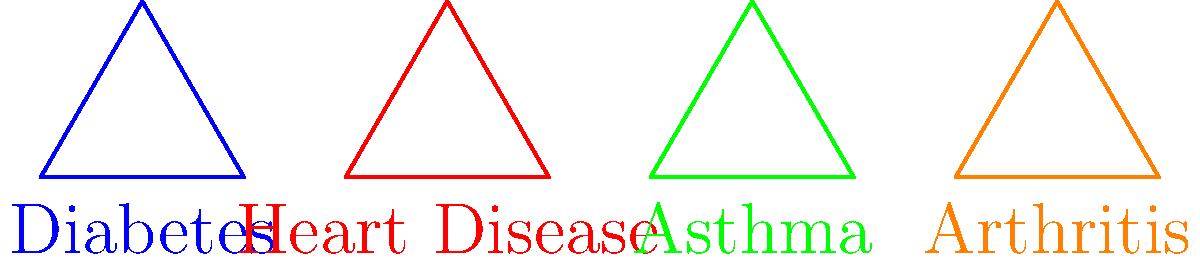In the diagram above, four equilateral triangles represent different coverage options for chronic conditions. Which two triangles are congruent, indicating equivalent coverage options? To determine which triangles are congruent, we need to compare their properties:

1. All triangles are equilateral, meaning all sides and angles are equal within each triangle.

2. To be congruent, two triangles must have the same size and shape.

3. Visually inspecting the diagram, we can see that:
   - The blue triangle (Diabetes) appears to be the smallest.
   - The red triangle (Heart Disease) and the green triangle (Asthma) appear to be the same size.
   - The orange triangle (Arthritis) appears to be the largest.

4. Since the red (Heart Disease) and green (Asthma) triangles appear to be the same size and shape, they are congruent.

5. This congruence suggests that the coverage options for Heart Disease and Asthma are equivalent in terms of benefits or cost structure.

Therefore, the congruent triangles representing equivalent coverage options are the ones for Heart Disease and Asthma.
Answer: Heart Disease and Asthma 